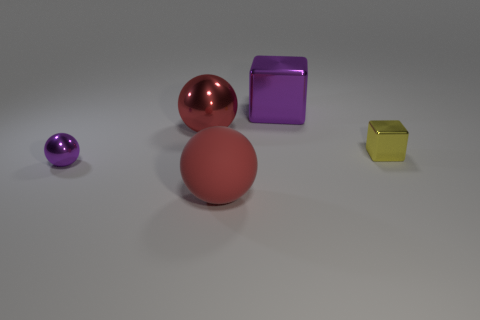Is there a pattern or theme to the arrangement of these objects? The objects seem to be arranged by size to some extent, with the small purple ball on the far left, the larger matte red ball in the center-left, the largest red shiny sphere in the center-right, and the yellow cube on the right. There's also a variety of colors and textures, which might suggest a theme of diversity or contrast between the objects. 